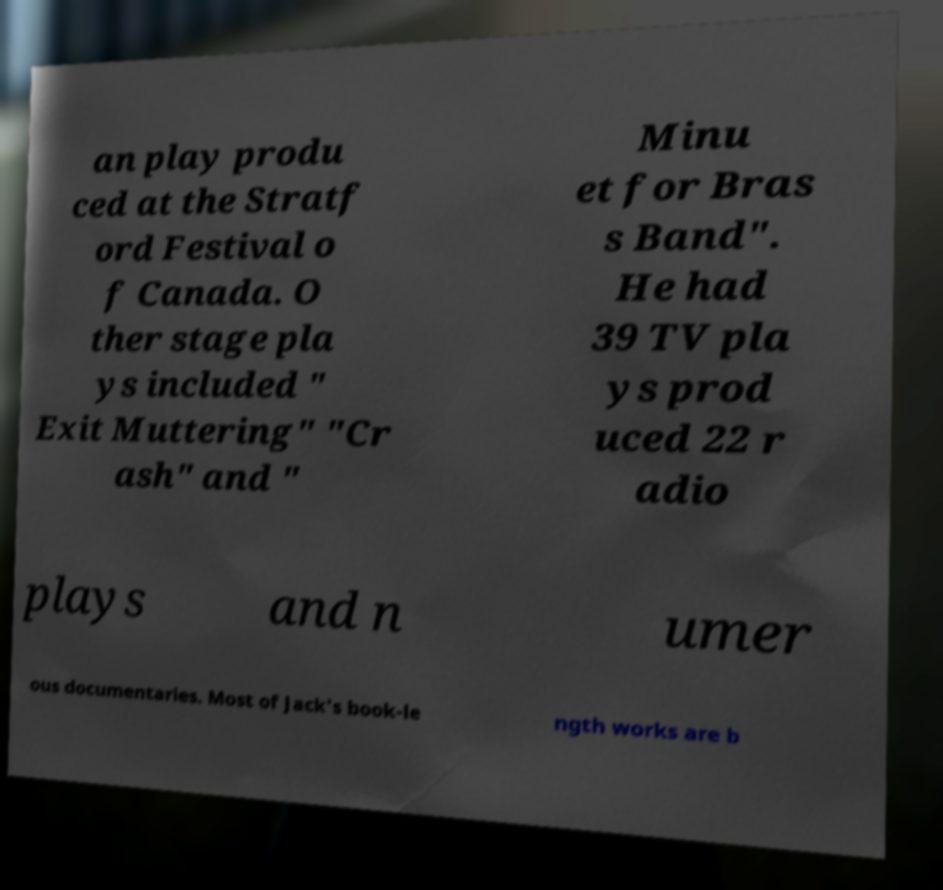For documentation purposes, I need the text within this image transcribed. Could you provide that? an play produ ced at the Stratf ord Festival o f Canada. O ther stage pla ys included " Exit Muttering" "Cr ash" and " Minu et for Bras s Band". He had 39 TV pla ys prod uced 22 r adio plays and n umer ous documentaries. Most of Jack's book-le ngth works are b 